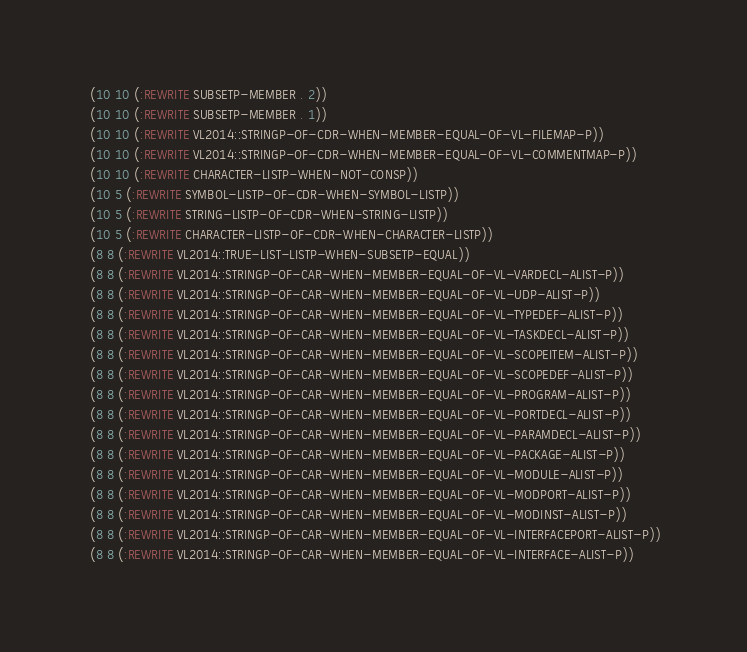<code> <loc_0><loc_0><loc_500><loc_500><_Lisp_> (10 10 (:REWRITE SUBSETP-MEMBER . 2))
 (10 10 (:REWRITE SUBSETP-MEMBER . 1))
 (10 10 (:REWRITE VL2014::STRINGP-OF-CDR-WHEN-MEMBER-EQUAL-OF-VL-FILEMAP-P))
 (10 10 (:REWRITE VL2014::STRINGP-OF-CDR-WHEN-MEMBER-EQUAL-OF-VL-COMMENTMAP-P))
 (10 10 (:REWRITE CHARACTER-LISTP-WHEN-NOT-CONSP))
 (10 5 (:REWRITE SYMBOL-LISTP-OF-CDR-WHEN-SYMBOL-LISTP))
 (10 5 (:REWRITE STRING-LISTP-OF-CDR-WHEN-STRING-LISTP))
 (10 5 (:REWRITE CHARACTER-LISTP-OF-CDR-WHEN-CHARACTER-LISTP))
 (8 8 (:REWRITE VL2014::TRUE-LIST-LISTP-WHEN-SUBSETP-EQUAL))
 (8 8 (:REWRITE VL2014::STRINGP-OF-CAR-WHEN-MEMBER-EQUAL-OF-VL-VARDECL-ALIST-P))
 (8 8 (:REWRITE VL2014::STRINGP-OF-CAR-WHEN-MEMBER-EQUAL-OF-VL-UDP-ALIST-P))
 (8 8 (:REWRITE VL2014::STRINGP-OF-CAR-WHEN-MEMBER-EQUAL-OF-VL-TYPEDEF-ALIST-P))
 (8 8 (:REWRITE VL2014::STRINGP-OF-CAR-WHEN-MEMBER-EQUAL-OF-VL-TASKDECL-ALIST-P))
 (8 8 (:REWRITE VL2014::STRINGP-OF-CAR-WHEN-MEMBER-EQUAL-OF-VL-SCOPEITEM-ALIST-P))
 (8 8 (:REWRITE VL2014::STRINGP-OF-CAR-WHEN-MEMBER-EQUAL-OF-VL-SCOPEDEF-ALIST-P))
 (8 8 (:REWRITE VL2014::STRINGP-OF-CAR-WHEN-MEMBER-EQUAL-OF-VL-PROGRAM-ALIST-P))
 (8 8 (:REWRITE VL2014::STRINGP-OF-CAR-WHEN-MEMBER-EQUAL-OF-VL-PORTDECL-ALIST-P))
 (8 8 (:REWRITE VL2014::STRINGP-OF-CAR-WHEN-MEMBER-EQUAL-OF-VL-PARAMDECL-ALIST-P))
 (8 8 (:REWRITE VL2014::STRINGP-OF-CAR-WHEN-MEMBER-EQUAL-OF-VL-PACKAGE-ALIST-P))
 (8 8 (:REWRITE VL2014::STRINGP-OF-CAR-WHEN-MEMBER-EQUAL-OF-VL-MODULE-ALIST-P))
 (8 8 (:REWRITE VL2014::STRINGP-OF-CAR-WHEN-MEMBER-EQUAL-OF-VL-MODPORT-ALIST-P))
 (8 8 (:REWRITE VL2014::STRINGP-OF-CAR-WHEN-MEMBER-EQUAL-OF-VL-MODINST-ALIST-P))
 (8 8 (:REWRITE VL2014::STRINGP-OF-CAR-WHEN-MEMBER-EQUAL-OF-VL-INTERFACEPORT-ALIST-P))
 (8 8 (:REWRITE VL2014::STRINGP-OF-CAR-WHEN-MEMBER-EQUAL-OF-VL-INTERFACE-ALIST-P))</code> 